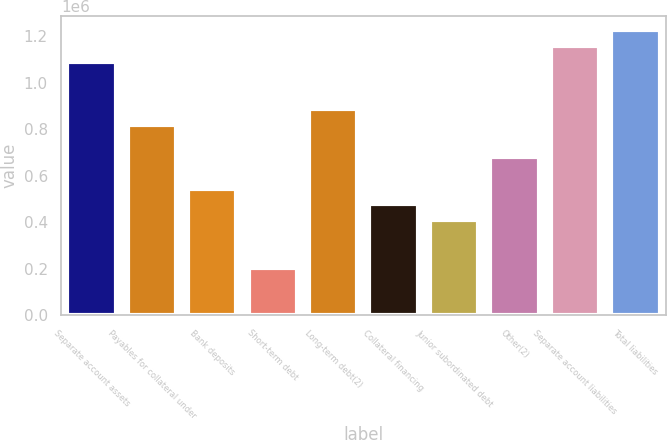<chart> <loc_0><loc_0><loc_500><loc_500><bar_chart><fcel>Separate account assets<fcel>Payables for collateral under<fcel>Bank deposits<fcel>Short-term debt<fcel>Long-term debt(2)<fcel>Collateral financing<fcel>Junior subordinated debt<fcel>Other(2)<fcel>Separate account liabilities<fcel>Total liabilities<nl><fcel>1.09087e+06<fcel>818151<fcel>545435<fcel>204539<fcel>886331<fcel>477255<fcel>409076<fcel>681793<fcel>1.15905e+06<fcel>1.22723e+06<nl></chart> 